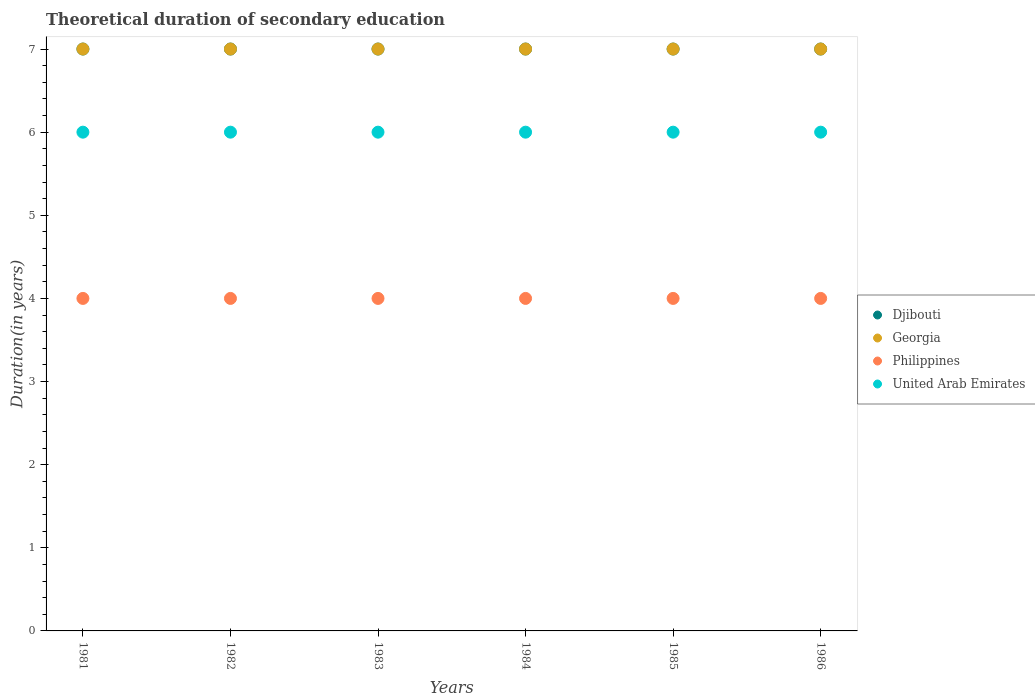How many different coloured dotlines are there?
Provide a short and direct response. 4. Is the number of dotlines equal to the number of legend labels?
Offer a very short reply. Yes. What is the total theoretical duration of secondary education in Djibouti in 1981?
Ensure brevity in your answer.  7. Across all years, what is the maximum total theoretical duration of secondary education in United Arab Emirates?
Your answer should be very brief. 6. Across all years, what is the minimum total theoretical duration of secondary education in Djibouti?
Give a very brief answer. 7. What is the total total theoretical duration of secondary education in Philippines in the graph?
Ensure brevity in your answer.  24. What is the difference between the total theoretical duration of secondary education in Georgia in 1981 and that in 1984?
Provide a succinct answer. 0. What is the difference between the total theoretical duration of secondary education in Philippines in 1986 and the total theoretical duration of secondary education in United Arab Emirates in 1982?
Your answer should be compact. -2. In the year 1985, what is the difference between the total theoretical duration of secondary education in Georgia and total theoretical duration of secondary education in Philippines?
Your answer should be very brief. 3. In how many years, is the total theoretical duration of secondary education in Djibouti greater than 1.2 years?
Your answer should be very brief. 6. What is the ratio of the total theoretical duration of secondary education in United Arab Emirates in 1981 to that in 1982?
Give a very brief answer. 1. Is the difference between the total theoretical duration of secondary education in Georgia in 1981 and 1984 greater than the difference between the total theoretical duration of secondary education in Philippines in 1981 and 1984?
Offer a very short reply. No. What is the difference between the highest and the second highest total theoretical duration of secondary education in United Arab Emirates?
Make the answer very short. 0. What is the difference between the highest and the lowest total theoretical duration of secondary education in United Arab Emirates?
Give a very brief answer. 0. In how many years, is the total theoretical duration of secondary education in Djibouti greater than the average total theoretical duration of secondary education in Djibouti taken over all years?
Offer a very short reply. 0. Is it the case that in every year, the sum of the total theoretical duration of secondary education in Djibouti and total theoretical duration of secondary education in United Arab Emirates  is greater than the total theoretical duration of secondary education in Georgia?
Provide a succinct answer. Yes. Is the total theoretical duration of secondary education in United Arab Emirates strictly less than the total theoretical duration of secondary education in Georgia over the years?
Your answer should be very brief. Yes. How many dotlines are there?
Your answer should be compact. 4. Are the values on the major ticks of Y-axis written in scientific E-notation?
Ensure brevity in your answer.  No. Does the graph contain any zero values?
Offer a very short reply. No. Where does the legend appear in the graph?
Your answer should be compact. Center right. How are the legend labels stacked?
Your answer should be compact. Vertical. What is the title of the graph?
Give a very brief answer. Theoretical duration of secondary education. Does "High income" appear as one of the legend labels in the graph?
Offer a very short reply. No. What is the label or title of the Y-axis?
Ensure brevity in your answer.  Duration(in years). What is the Duration(in years) of Philippines in 1981?
Your answer should be compact. 4. What is the Duration(in years) of Djibouti in 1982?
Offer a terse response. 7. What is the Duration(in years) in United Arab Emirates in 1982?
Provide a short and direct response. 6. What is the Duration(in years) of Georgia in 1983?
Make the answer very short. 7. What is the Duration(in years) of Djibouti in 1984?
Your answer should be very brief. 7. What is the Duration(in years) in Georgia in 1984?
Offer a very short reply. 7. What is the Duration(in years) in Philippines in 1984?
Provide a succinct answer. 4. What is the Duration(in years) in Djibouti in 1985?
Your response must be concise. 7. What is the Duration(in years) of Djibouti in 1986?
Keep it short and to the point. 7. What is the Duration(in years) in United Arab Emirates in 1986?
Offer a terse response. 6. Across all years, what is the maximum Duration(in years) in Djibouti?
Your response must be concise. 7. Across all years, what is the maximum Duration(in years) in United Arab Emirates?
Provide a succinct answer. 6. Across all years, what is the minimum Duration(in years) of Georgia?
Keep it short and to the point. 7. What is the total Duration(in years) in Georgia in the graph?
Provide a short and direct response. 42. What is the difference between the Duration(in years) in Djibouti in 1981 and that in 1982?
Offer a terse response. 0. What is the difference between the Duration(in years) of Georgia in 1981 and that in 1982?
Your response must be concise. 0. What is the difference between the Duration(in years) of Djibouti in 1981 and that in 1983?
Offer a very short reply. 0. What is the difference between the Duration(in years) of Djibouti in 1981 and that in 1984?
Offer a very short reply. 0. What is the difference between the Duration(in years) in Georgia in 1981 and that in 1984?
Give a very brief answer. 0. What is the difference between the Duration(in years) of Philippines in 1981 and that in 1984?
Ensure brevity in your answer.  0. What is the difference between the Duration(in years) of United Arab Emirates in 1981 and that in 1984?
Your response must be concise. 0. What is the difference between the Duration(in years) in Djibouti in 1981 and that in 1985?
Your answer should be compact. 0. What is the difference between the Duration(in years) in Philippines in 1981 and that in 1985?
Provide a succinct answer. 0. What is the difference between the Duration(in years) of United Arab Emirates in 1981 and that in 1985?
Your response must be concise. 0. What is the difference between the Duration(in years) in Djibouti in 1982 and that in 1983?
Your answer should be compact. 0. What is the difference between the Duration(in years) of Georgia in 1982 and that in 1983?
Your response must be concise. 0. What is the difference between the Duration(in years) in United Arab Emirates in 1982 and that in 1983?
Ensure brevity in your answer.  0. What is the difference between the Duration(in years) of Djibouti in 1982 and that in 1984?
Keep it short and to the point. 0. What is the difference between the Duration(in years) in Georgia in 1982 and that in 1984?
Your answer should be compact. 0. What is the difference between the Duration(in years) of United Arab Emirates in 1982 and that in 1984?
Give a very brief answer. 0. What is the difference between the Duration(in years) of Djibouti in 1982 and that in 1985?
Provide a short and direct response. 0. What is the difference between the Duration(in years) of Georgia in 1982 and that in 1986?
Your answer should be very brief. 0. What is the difference between the Duration(in years) in Djibouti in 1983 and that in 1984?
Offer a terse response. 0. What is the difference between the Duration(in years) of Georgia in 1983 and that in 1984?
Offer a terse response. 0. What is the difference between the Duration(in years) in Philippines in 1983 and that in 1984?
Provide a succinct answer. 0. What is the difference between the Duration(in years) in United Arab Emirates in 1983 and that in 1984?
Offer a very short reply. 0. What is the difference between the Duration(in years) of Philippines in 1983 and that in 1985?
Your response must be concise. 0. What is the difference between the Duration(in years) in United Arab Emirates in 1983 and that in 1985?
Provide a short and direct response. 0. What is the difference between the Duration(in years) in Djibouti in 1983 and that in 1986?
Ensure brevity in your answer.  0. What is the difference between the Duration(in years) of United Arab Emirates in 1983 and that in 1986?
Offer a terse response. 0. What is the difference between the Duration(in years) in Djibouti in 1984 and that in 1985?
Provide a succinct answer. 0. What is the difference between the Duration(in years) of United Arab Emirates in 1984 and that in 1985?
Give a very brief answer. 0. What is the difference between the Duration(in years) of Philippines in 1984 and that in 1986?
Your response must be concise. 0. What is the difference between the Duration(in years) in United Arab Emirates in 1985 and that in 1986?
Your answer should be very brief. 0. What is the difference between the Duration(in years) in Djibouti in 1981 and the Duration(in years) in Georgia in 1982?
Your answer should be very brief. 0. What is the difference between the Duration(in years) in Djibouti in 1981 and the Duration(in years) in Philippines in 1982?
Give a very brief answer. 3. What is the difference between the Duration(in years) in Georgia in 1981 and the Duration(in years) in Philippines in 1982?
Give a very brief answer. 3. What is the difference between the Duration(in years) in Georgia in 1981 and the Duration(in years) in United Arab Emirates in 1982?
Provide a short and direct response. 1. What is the difference between the Duration(in years) of Djibouti in 1981 and the Duration(in years) of Georgia in 1983?
Give a very brief answer. 0. What is the difference between the Duration(in years) in Djibouti in 1981 and the Duration(in years) in Philippines in 1983?
Offer a terse response. 3. What is the difference between the Duration(in years) of Georgia in 1981 and the Duration(in years) of Philippines in 1983?
Ensure brevity in your answer.  3. What is the difference between the Duration(in years) of Philippines in 1981 and the Duration(in years) of United Arab Emirates in 1983?
Provide a succinct answer. -2. What is the difference between the Duration(in years) in Djibouti in 1981 and the Duration(in years) in Georgia in 1984?
Your response must be concise. 0. What is the difference between the Duration(in years) in Djibouti in 1981 and the Duration(in years) in Philippines in 1984?
Your response must be concise. 3. What is the difference between the Duration(in years) in Georgia in 1981 and the Duration(in years) in Philippines in 1984?
Your answer should be very brief. 3. What is the difference between the Duration(in years) in Georgia in 1981 and the Duration(in years) in United Arab Emirates in 1984?
Provide a succinct answer. 1. What is the difference between the Duration(in years) of Philippines in 1981 and the Duration(in years) of United Arab Emirates in 1984?
Provide a short and direct response. -2. What is the difference between the Duration(in years) in Djibouti in 1981 and the Duration(in years) in Georgia in 1985?
Make the answer very short. 0. What is the difference between the Duration(in years) of Djibouti in 1981 and the Duration(in years) of United Arab Emirates in 1985?
Make the answer very short. 1. What is the difference between the Duration(in years) of Georgia in 1981 and the Duration(in years) of United Arab Emirates in 1985?
Provide a succinct answer. 1. What is the difference between the Duration(in years) of Djibouti in 1981 and the Duration(in years) of Philippines in 1986?
Ensure brevity in your answer.  3. What is the difference between the Duration(in years) in Philippines in 1981 and the Duration(in years) in United Arab Emirates in 1986?
Make the answer very short. -2. What is the difference between the Duration(in years) in Djibouti in 1982 and the Duration(in years) in United Arab Emirates in 1983?
Make the answer very short. 1. What is the difference between the Duration(in years) of Georgia in 1982 and the Duration(in years) of United Arab Emirates in 1983?
Your answer should be compact. 1. What is the difference between the Duration(in years) of Philippines in 1982 and the Duration(in years) of United Arab Emirates in 1983?
Provide a short and direct response. -2. What is the difference between the Duration(in years) of Georgia in 1982 and the Duration(in years) of Philippines in 1984?
Ensure brevity in your answer.  3. What is the difference between the Duration(in years) of Georgia in 1982 and the Duration(in years) of United Arab Emirates in 1984?
Provide a succinct answer. 1. What is the difference between the Duration(in years) of Philippines in 1982 and the Duration(in years) of United Arab Emirates in 1984?
Ensure brevity in your answer.  -2. What is the difference between the Duration(in years) of Djibouti in 1982 and the Duration(in years) of Philippines in 1985?
Offer a very short reply. 3. What is the difference between the Duration(in years) of Djibouti in 1982 and the Duration(in years) of United Arab Emirates in 1985?
Make the answer very short. 1. What is the difference between the Duration(in years) in Djibouti in 1982 and the Duration(in years) in United Arab Emirates in 1986?
Keep it short and to the point. 1. What is the difference between the Duration(in years) in Georgia in 1982 and the Duration(in years) in Philippines in 1986?
Your answer should be very brief. 3. What is the difference between the Duration(in years) in Philippines in 1982 and the Duration(in years) in United Arab Emirates in 1986?
Your answer should be very brief. -2. What is the difference between the Duration(in years) of Djibouti in 1983 and the Duration(in years) of Georgia in 1984?
Offer a terse response. 0. What is the difference between the Duration(in years) of Djibouti in 1983 and the Duration(in years) of Philippines in 1984?
Offer a terse response. 3. What is the difference between the Duration(in years) in Djibouti in 1983 and the Duration(in years) in United Arab Emirates in 1984?
Give a very brief answer. 1. What is the difference between the Duration(in years) of Georgia in 1983 and the Duration(in years) of Philippines in 1984?
Give a very brief answer. 3. What is the difference between the Duration(in years) of Georgia in 1983 and the Duration(in years) of United Arab Emirates in 1984?
Ensure brevity in your answer.  1. What is the difference between the Duration(in years) of Philippines in 1983 and the Duration(in years) of United Arab Emirates in 1984?
Your response must be concise. -2. What is the difference between the Duration(in years) in Djibouti in 1983 and the Duration(in years) in Georgia in 1985?
Your answer should be very brief. 0. What is the difference between the Duration(in years) of Djibouti in 1983 and the Duration(in years) of Philippines in 1985?
Provide a succinct answer. 3. What is the difference between the Duration(in years) in Djibouti in 1983 and the Duration(in years) in United Arab Emirates in 1985?
Offer a terse response. 1. What is the difference between the Duration(in years) of Georgia in 1983 and the Duration(in years) of Philippines in 1985?
Provide a succinct answer. 3. What is the difference between the Duration(in years) of Philippines in 1983 and the Duration(in years) of United Arab Emirates in 1985?
Ensure brevity in your answer.  -2. What is the difference between the Duration(in years) of Djibouti in 1983 and the Duration(in years) of United Arab Emirates in 1986?
Offer a very short reply. 1. What is the difference between the Duration(in years) in Georgia in 1983 and the Duration(in years) in Philippines in 1986?
Offer a terse response. 3. What is the difference between the Duration(in years) in Georgia in 1983 and the Duration(in years) in United Arab Emirates in 1986?
Make the answer very short. 1. What is the difference between the Duration(in years) of Djibouti in 1984 and the Duration(in years) of United Arab Emirates in 1985?
Ensure brevity in your answer.  1. What is the difference between the Duration(in years) of Georgia in 1984 and the Duration(in years) of Philippines in 1985?
Ensure brevity in your answer.  3. What is the difference between the Duration(in years) in Djibouti in 1984 and the Duration(in years) in United Arab Emirates in 1986?
Your response must be concise. 1. What is the difference between the Duration(in years) in Georgia in 1984 and the Duration(in years) in United Arab Emirates in 1986?
Your answer should be compact. 1. What is the difference between the Duration(in years) of Djibouti in 1985 and the Duration(in years) of United Arab Emirates in 1986?
Give a very brief answer. 1. What is the difference between the Duration(in years) of Philippines in 1985 and the Duration(in years) of United Arab Emirates in 1986?
Provide a short and direct response. -2. What is the average Duration(in years) of Georgia per year?
Make the answer very short. 7. What is the average Duration(in years) of United Arab Emirates per year?
Provide a succinct answer. 6. In the year 1981, what is the difference between the Duration(in years) of Djibouti and Duration(in years) of United Arab Emirates?
Your response must be concise. 1. In the year 1981, what is the difference between the Duration(in years) in Georgia and Duration(in years) in Philippines?
Provide a succinct answer. 3. In the year 1981, what is the difference between the Duration(in years) in Philippines and Duration(in years) in United Arab Emirates?
Your answer should be very brief. -2. In the year 1982, what is the difference between the Duration(in years) of Djibouti and Duration(in years) of Philippines?
Keep it short and to the point. 3. In the year 1982, what is the difference between the Duration(in years) of Djibouti and Duration(in years) of United Arab Emirates?
Give a very brief answer. 1. In the year 1982, what is the difference between the Duration(in years) in Georgia and Duration(in years) in United Arab Emirates?
Offer a very short reply. 1. In the year 1982, what is the difference between the Duration(in years) of Philippines and Duration(in years) of United Arab Emirates?
Your answer should be compact. -2. In the year 1983, what is the difference between the Duration(in years) of Georgia and Duration(in years) of Philippines?
Provide a succinct answer. 3. In the year 1984, what is the difference between the Duration(in years) of Djibouti and Duration(in years) of United Arab Emirates?
Your answer should be compact. 1. In the year 1984, what is the difference between the Duration(in years) of Georgia and Duration(in years) of Philippines?
Keep it short and to the point. 3. In the year 1985, what is the difference between the Duration(in years) in Djibouti and Duration(in years) in Philippines?
Provide a short and direct response. 3. In the year 1985, what is the difference between the Duration(in years) of Djibouti and Duration(in years) of United Arab Emirates?
Your response must be concise. 1. In the year 1985, what is the difference between the Duration(in years) of Georgia and Duration(in years) of Philippines?
Your answer should be very brief. 3. In the year 1985, what is the difference between the Duration(in years) in Georgia and Duration(in years) in United Arab Emirates?
Your answer should be very brief. 1. In the year 1985, what is the difference between the Duration(in years) of Philippines and Duration(in years) of United Arab Emirates?
Your answer should be compact. -2. In the year 1986, what is the difference between the Duration(in years) of Georgia and Duration(in years) of United Arab Emirates?
Keep it short and to the point. 1. What is the ratio of the Duration(in years) of Philippines in 1981 to that in 1982?
Your answer should be compact. 1. What is the ratio of the Duration(in years) in Djibouti in 1981 to that in 1983?
Your response must be concise. 1. What is the ratio of the Duration(in years) in Philippines in 1981 to that in 1983?
Provide a short and direct response. 1. What is the ratio of the Duration(in years) in Djibouti in 1981 to that in 1985?
Your answer should be very brief. 1. What is the ratio of the Duration(in years) in Philippines in 1981 to that in 1985?
Ensure brevity in your answer.  1. What is the ratio of the Duration(in years) of United Arab Emirates in 1981 to that in 1986?
Offer a very short reply. 1. What is the ratio of the Duration(in years) of Georgia in 1982 to that in 1983?
Your answer should be compact. 1. What is the ratio of the Duration(in years) in United Arab Emirates in 1982 to that in 1983?
Offer a very short reply. 1. What is the ratio of the Duration(in years) of Georgia in 1982 to that in 1984?
Offer a terse response. 1. What is the ratio of the Duration(in years) of Djibouti in 1982 to that in 1985?
Make the answer very short. 1. What is the ratio of the Duration(in years) of Georgia in 1982 to that in 1985?
Your response must be concise. 1. What is the ratio of the Duration(in years) of Philippines in 1982 to that in 1986?
Provide a succinct answer. 1. What is the ratio of the Duration(in years) of Djibouti in 1983 to that in 1984?
Your response must be concise. 1. What is the ratio of the Duration(in years) of Georgia in 1983 to that in 1984?
Give a very brief answer. 1. What is the ratio of the Duration(in years) in Georgia in 1983 to that in 1986?
Your answer should be very brief. 1. What is the ratio of the Duration(in years) in Philippines in 1983 to that in 1986?
Give a very brief answer. 1. What is the ratio of the Duration(in years) of United Arab Emirates in 1983 to that in 1986?
Give a very brief answer. 1. What is the ratio of the Duration(in years) in Djibouti in 1984 to that in 1986?
Provide a succinct answer. 1. What is the ratio of the Duration(in years) in Georgia in 1984 to that in 1986?
Provide a short and direct response. 1. What is the ratio of the Duration(in years) in Djibouti in 1985 to that in 1986?
Keep it short and to the point. 1. What is the ratio of the Duration(in years) in Georgia in 1985 to that in 1986?
Ensure brevity in your answer.  1. What is the ratio of the Duration(in years) in Philippines in 1985 to that in 1986?
Make the answer very short. 1. What is the ratio of the Duration(in years) in United Arab Emirates in 1985 to that in 1986?
Provide a short and direct response. 1. What is the difference between the highest and the second highest Duration(in years) in Georgia?
Your answer should be compact. 0. What is the difference between the highest and the second highest Duration(in years) in United Arab Emirates?
Provide a short and direct response. 0. What is the difference between the highest and the lowest Duration(in years) in Djibouti?
Your answer should be compact. 0. What is the difference between the highest and the lowest Duration(in years) of Philippines?
Your answer should be very brief. 0. What is the difference between the highest and the lowest Duration(in years) of United Arab Emirates?
Offer a very short reply. 0. 